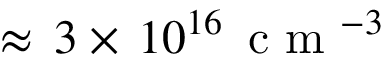<formula> <loc_0><loc_0><loc_500><loc_500>\approx \, 3 \times \, 1 0 ^ { 1 6 } \, c m ^ { - 3 }</formula> 